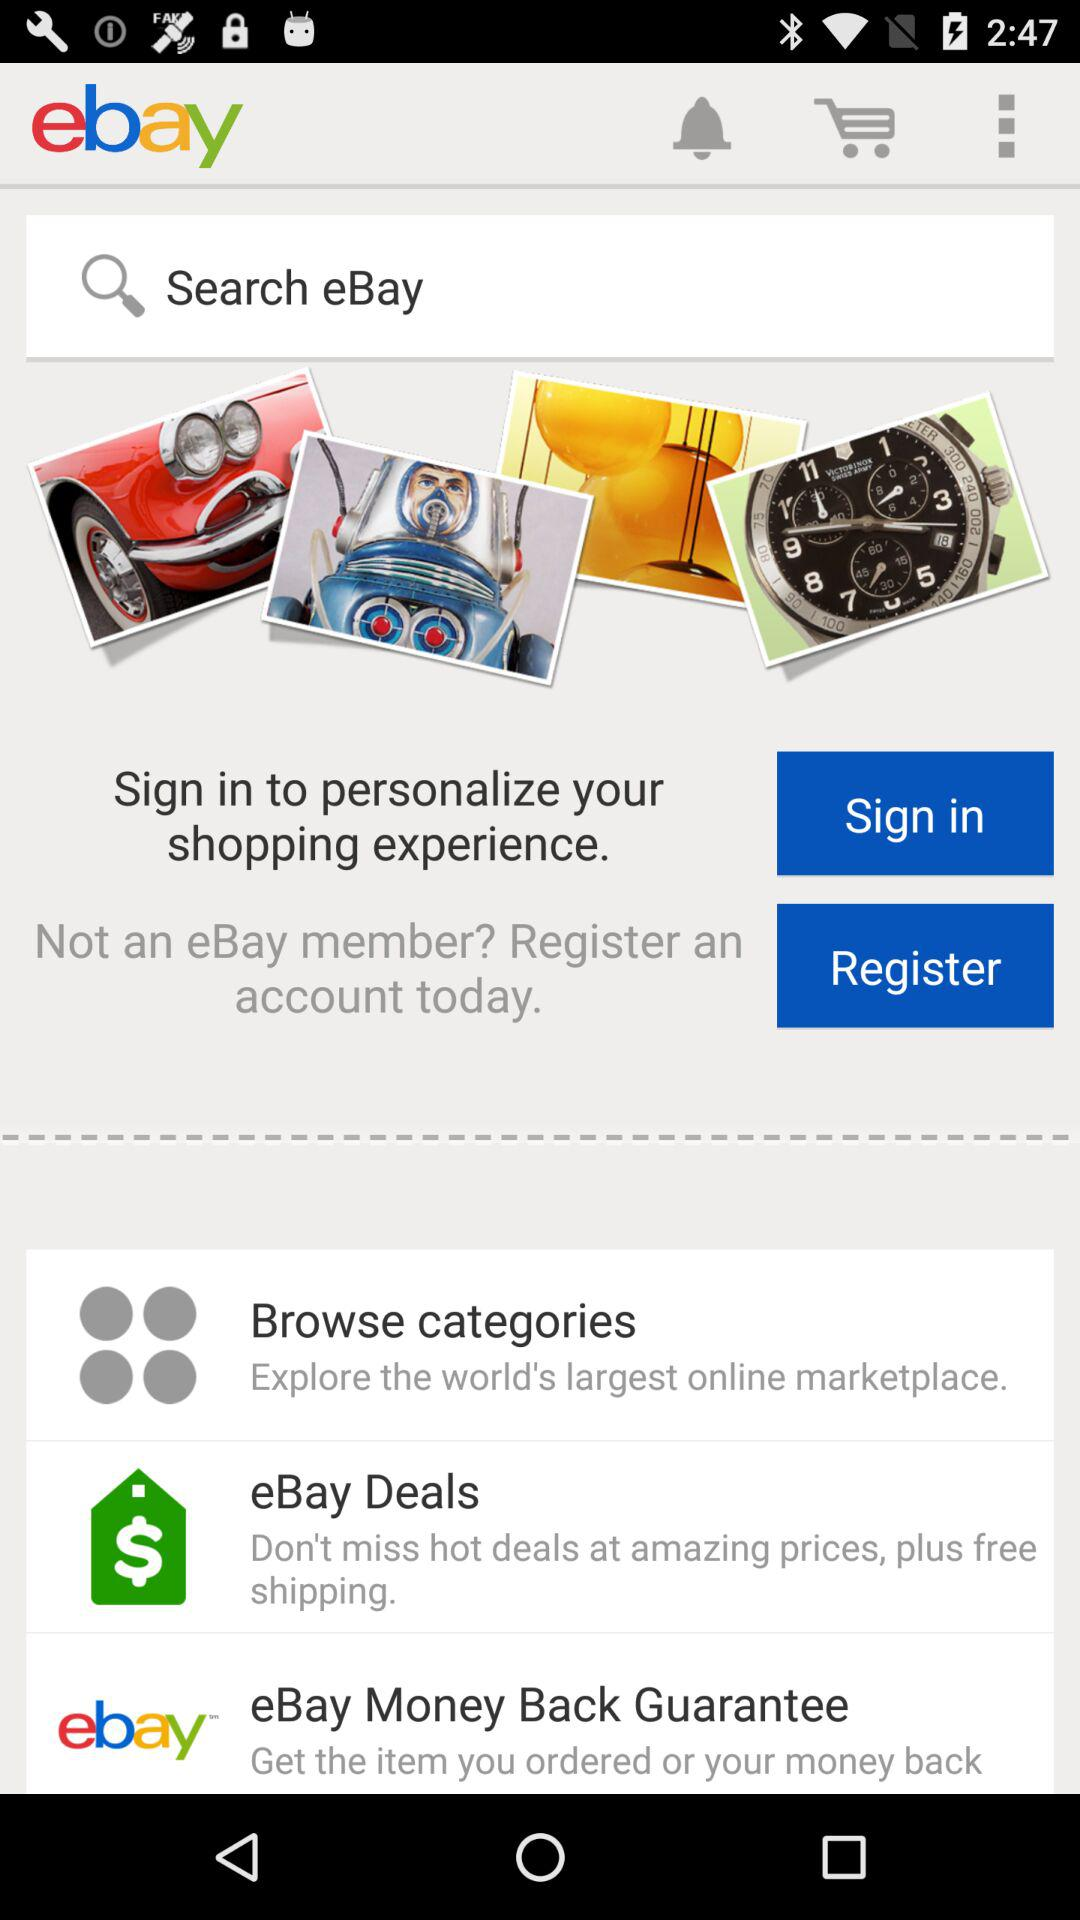Is the user an "eBay" member?
When the provided information is insufficient, respond with <no answer>. <no answer> 